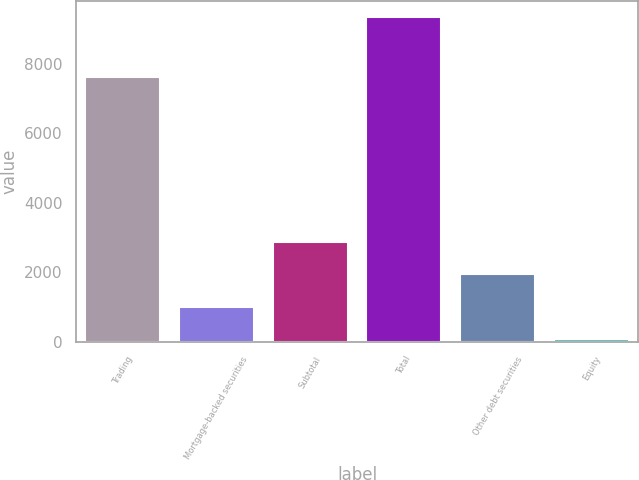<chart> <loc_0><loc_0><loc_500><loc_500><bar_chart><fcel>Trading<fcel>Mortgage-backed securities<fcel>Subtotal<fcel>Total<fcel>Other debt securities<fcel>Equity<nl><fcel>7637<fcel>1010.5<fcel>2863.5<fcel>9349<fcel>1937<fcel>84<nl></chart> 